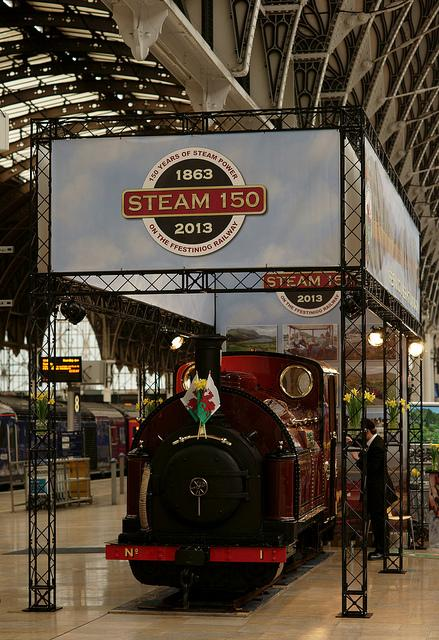Which anniversary is being celebrated?

Choices:
A) 150
B) 2013
C) 100
D) 1863 150 